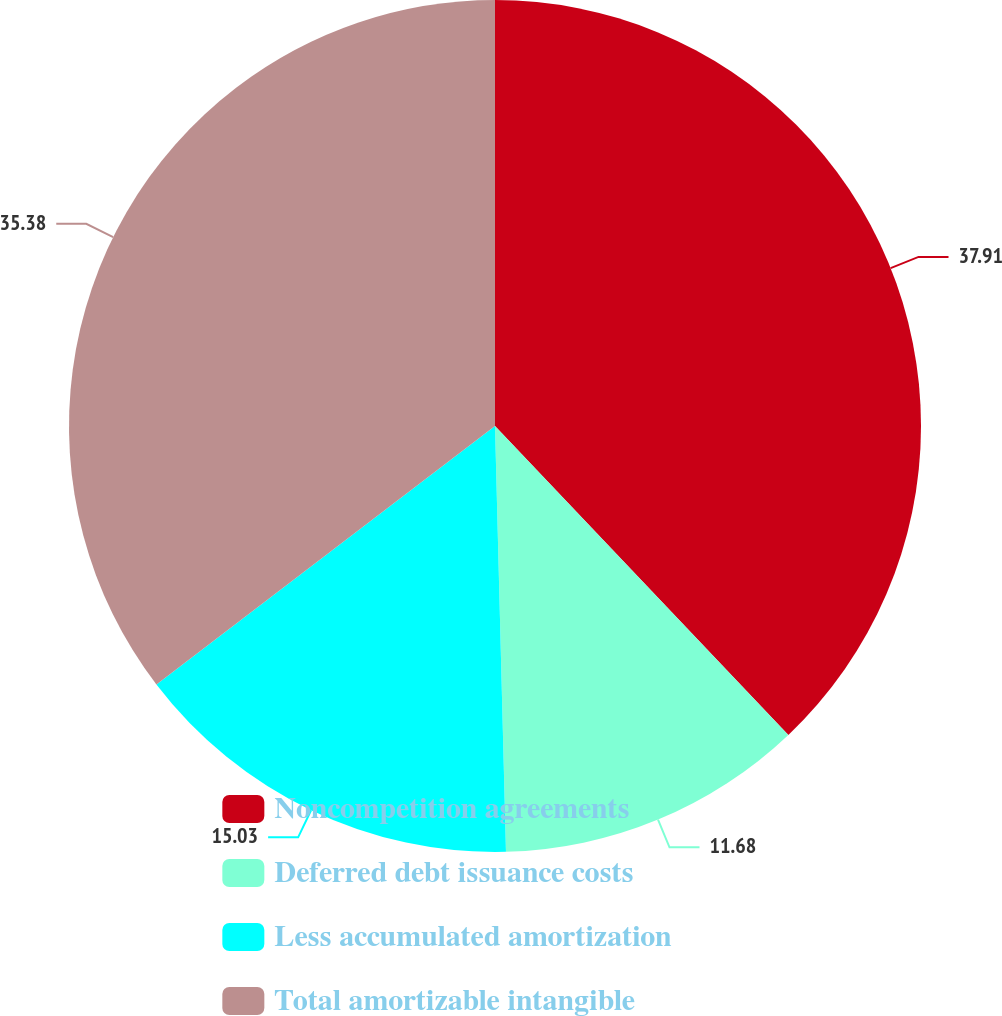Convert chart. <chart><loc_0><loc_0><loc_500><loc_500><pie_chart><fcel>Noncompetition agreements<fcel>Deferred debt issuance costs<fcel>Less accumulated amortization<fcel>Total amortizable intangible<nl><fcel>37.91%<fcel>11.68%<fcel>15.03%<fcel>35.38%<nl></chart> 